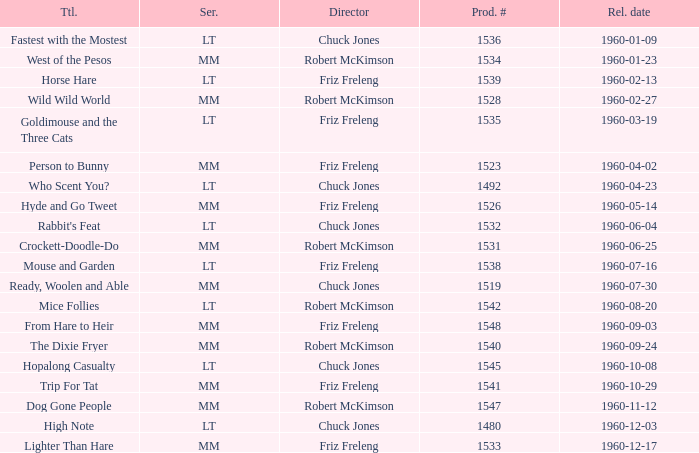What is the production number for the episode directed by Robert McKimson named Mice Follies? 1.0. 